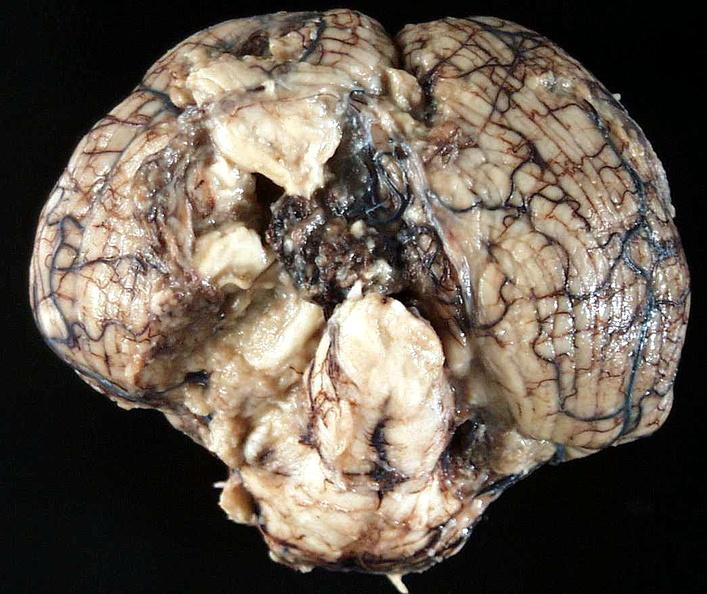s brain present?
Answer the question using a single word or phrase. No 